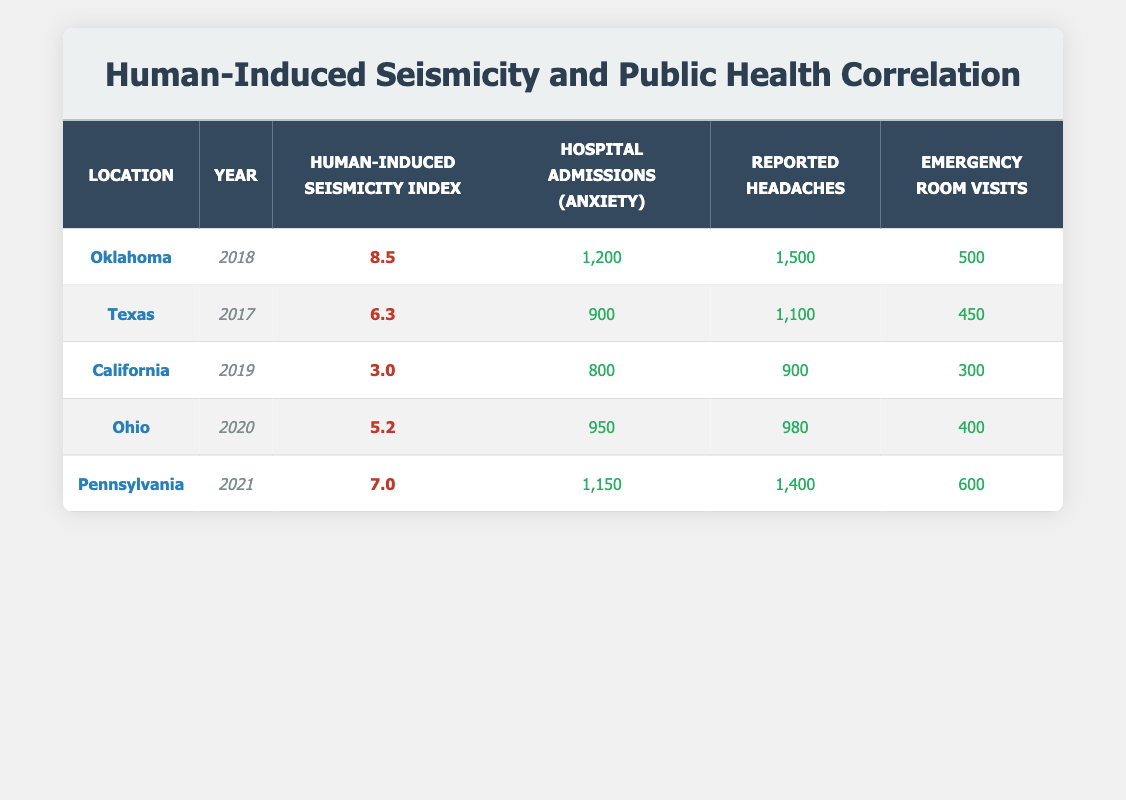What is the human-induced seismicity index for Oklahoma in 2018? The table shows that Oklahoma has a human-induced seismicity index of 8.5 for the year 2018.
Answer: 8.5 What was the number of hospital admissions due to anxiety in Pennsylvania in 2021? Referring to the table, Pennsylvania had 1,150 hospital admissions due to anxiety in 2021.
Answer: 1,150 Which location reported the highest number of emergency room visits, and what was that number? By reviewing the table, we see that Oklahoma reported the highest emergency room visits at 500.
Answer: Oklahoma; 500 Calculate the average number of reported cases of headaches across all locations. Adding the reported cases of headaches (1500 + 1100 + 900 + 980 + 1400) gives us 4880. There are 5 locations, so the average is 4880 / 5 = 976.
Answer: 976 Is the human-induced seismicity index in California greater than 4? The table indicates that California has a seismicity index of 3.0, which is not greater than 4.
Answer: No What is the difference in hospital admissions due to anxiety between Oklahoma and Texas? Oklahoma had 1,200 hospital admissions, while Texas had 900. The difference is 1,200 - 900 = 300.
Answer: 300 In which year did Ohio experience the lowest human-induced seismicity index, and what was that index? The table shows that Ohio had a seismicity index of 5.2 in 2020, which is lower than the values of all other locations.
Answer: 2020; 5.2 Does the data suggest a correlation between higher human-induced seismicity index and increased emergency room visits? By analyzing the data, locations with higher seismicity indices (like Oklahoma and Pennsylvania) also report higher emergency room visits (500 and 600), whereas locations with lower indices (like California) have fewer visits (300). This suggests a positive correlation.
Answer: Yes What is the total number of hospital admissions due to anxiety across all locations? Summing the hospital admissions (1200 + 900 + 800 + 950 + 1150) gives 4,000.
Answer: 4,000 